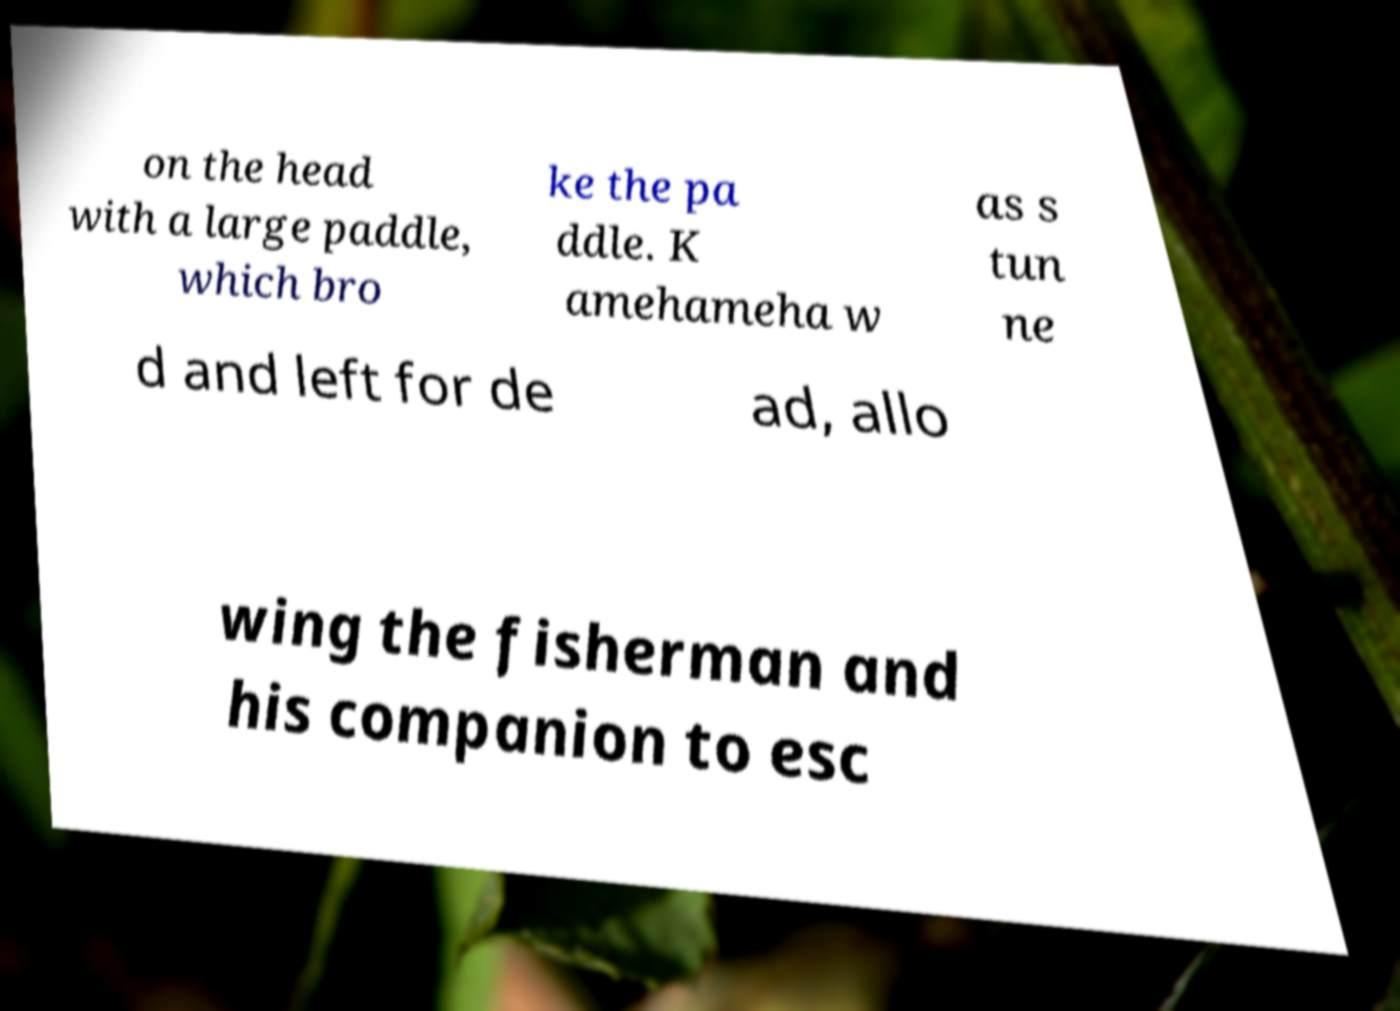There's text embedded in this image that I need extracted. Can you transcribe it verbatim? on the head with a large paddle, which bro ke the pa ddle. K amehameha w as s tun ne d and left for de ad, allo wing the fisherman and his companion to esc 